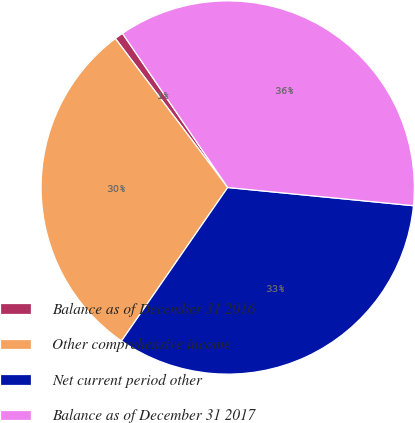Convert chart. <chart><loc_0><loc_0><loc_500><loc_500><pie_chart><fcel>Balance as of December 31 2016<fcel>Other comprehensive income<fcel>Net current period other<fcel>Balance as of December 31 2017<nl><fcel>0.75%<fcel>30.08%<fcel>33.08%<fcel>36.09%<nl></chart> 